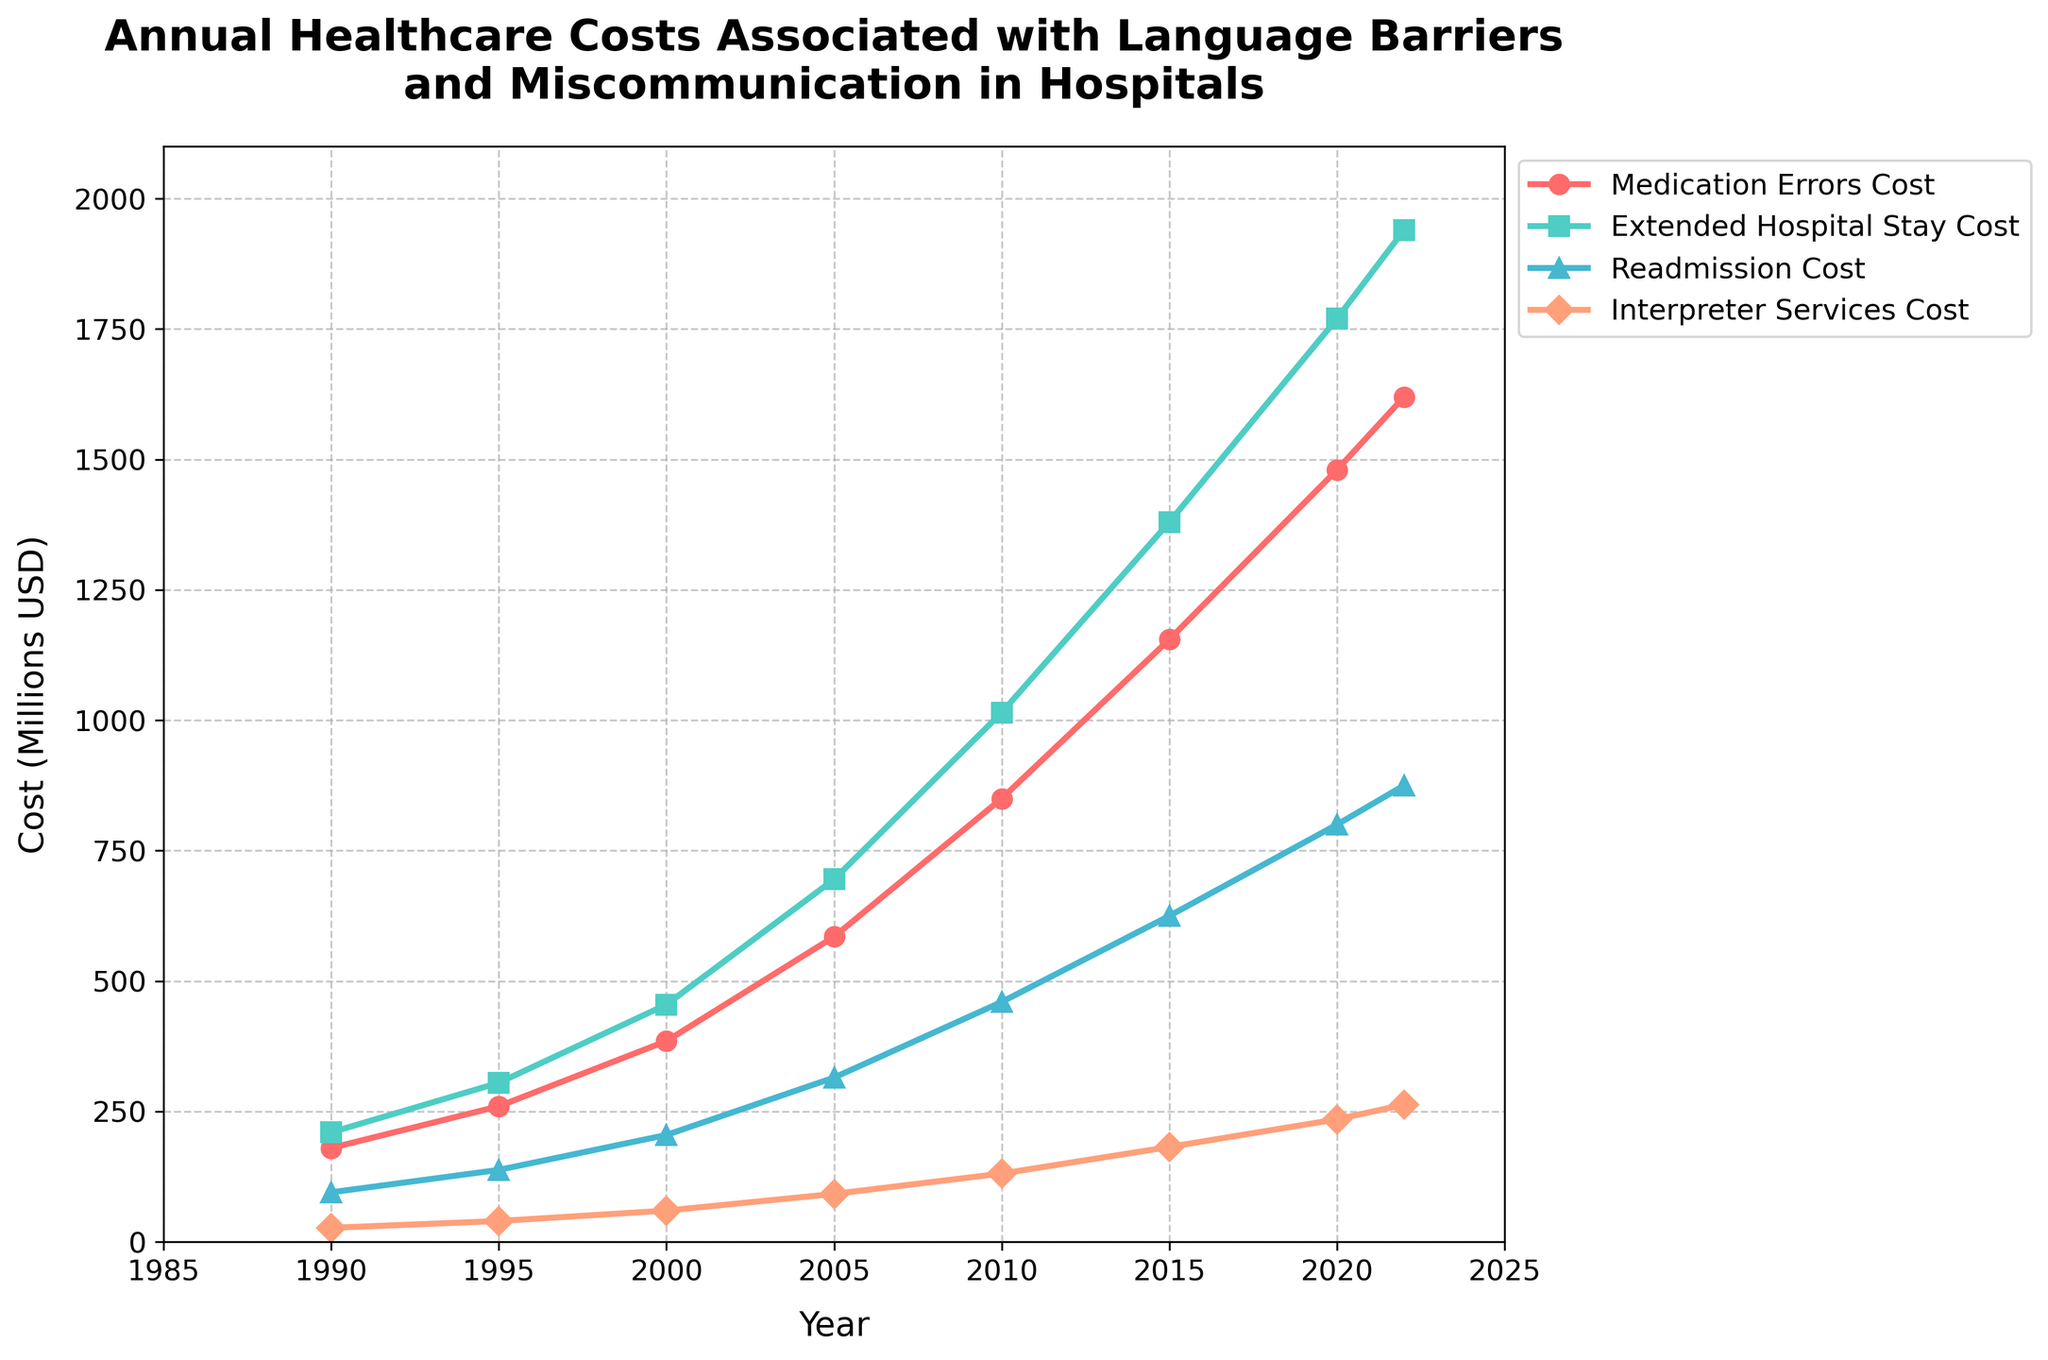What's the trend of the total cost from 1990 to 2022? The total cost has been consistently increasing from 1990 to 2022. We can see that it starts from 512 million USD in 1990 and reaches 4698 million USD in 2022.
Answer: Increasing Which year experienced the highest cost due to readmission? By looking at the Readmission Cost line, the highest point is in the year 2022, where the cost is 875 million USD.
Answer: 2022 How does the cost for interpreter services in 2020 compare to that in 2015? In 2015, the cost for interpreter services was 182 million USD, and in 2020, it increased to 235 million USD. Therefore, there was an increase from 2015 to 2020.
Answer: Increased What is the difference between the cost of extended hospital stay in 2010 and 1995? The cost of extended hospital stay in 1995 was 305 million USD, and in 2010, it was 1015 million USD. The difference is 1015 - 305 = 710 million USD.
Answer: 710 million USD What is the average cost of medication errors from 2000 to 2020? The costs of medication errors from 2000 to 2020 are 385, 585, 850, 1155, and 1480 million USD. The sum of these values is 4455 million USD. There are 5 data points, so the average is 4455 / 5 = 891 million USD.
Answer: 891 million USD Between which years did the cost of readmission see the highest growth? The cost of readmission increased in all periods, but the highest growth is between 2000 (205 million USD) and 2005 (315 million USD), which is an increase of 110 million USD.
Answer: 2000 to 2005 What proportion of the total cost in 2022 is the interpreter services cost? The total cost in 2022 is 4698 million USD, and the interpreter services cost is 263 million USD. The proportion is 263 / 4698 = 0.056, which is approximately 5.6%.
Answer: 5.6% In which year did the total cost surpass 2000 million USD? The total cost surpassed 2000 million USD in the year 2010, where it reached 2456 million USD.
Answer: 2010 What is the combined cost of medication errors and extended hospital stays in 2005? The cost of medication errors in 2005 is 585 million USD, and extended hospital stays cost 695 million USD. Combined, this is 585 + 695 = 1280 million USD.
Answer: 1280 million USD 